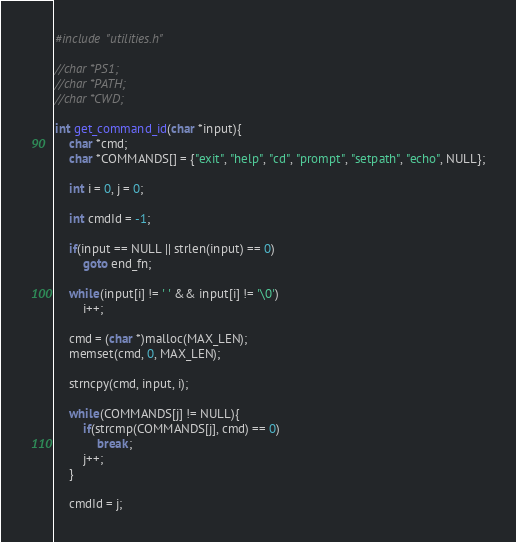Convert code to text. <code><loc_0><loc_0><loc_500><loc_500><_C_>#include "utilities.h"

//char *PS1;
//char *PATH;
//char *CWD;

int get_command_id(char *input){
    char *cmd;
    char *COMMANDS[] = {"exit", "help", "cd", "prompt", "setpath", "echo", NULL};

    int i = 0, j = 0;
    
    int cmdId = -1;

    if(input == NULL || strlen(input) == 0)
        goto end_fn;
    
    while(input[i] != ' ' && input[i] != '\0')
        i++;

    cmd = (char *)malloc(MAX_LEN);
    memset(cmd, 0, MAX_LEN);

    strncpy(cmd, input, i);
    
    while(COMMANDS[j] != NULL){
        if(strcmp(COMMANDS[j], cmd) == 0)
            break;
        j++;
    }
    
    cmdId = j;
</code> 